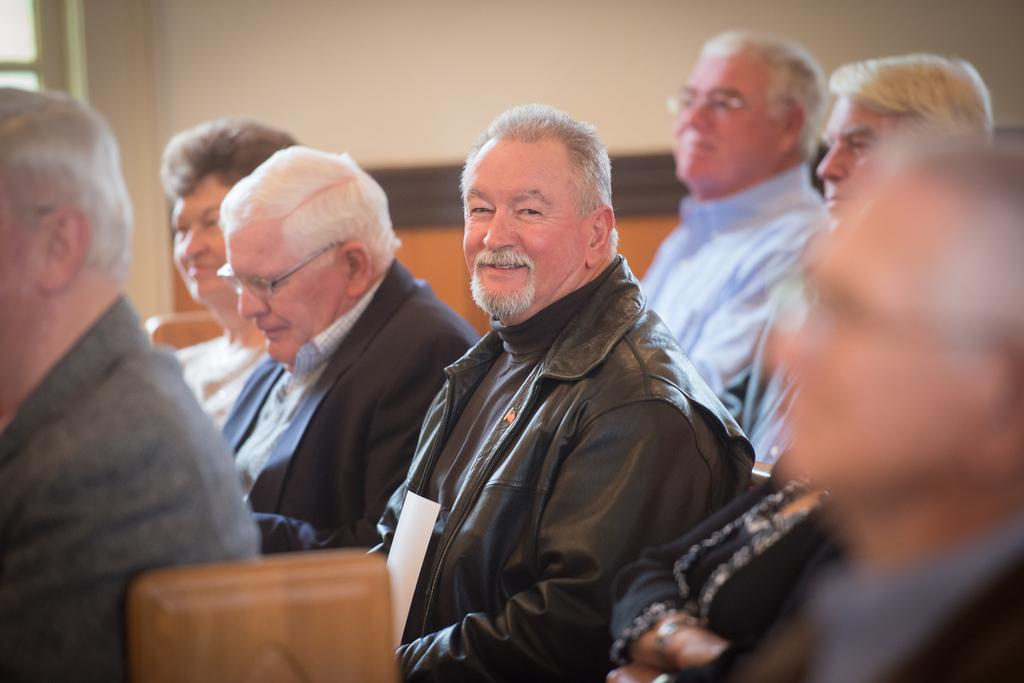What are the people in the image doing? The people in the image are sitting. What can be seen in the background of the image? There is a wall in the background of the image. How does the image control the tax rate for the people in the image? The image does not control the tax rate; it is a static representation and cannot influence real-world factors like tax rates. 